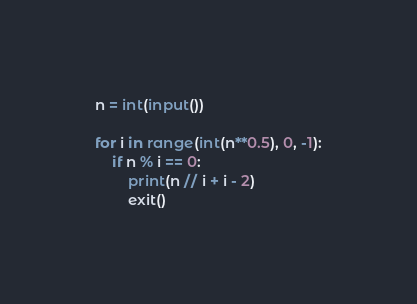<code> <loc_0><loc_0><loc_500><loc_500><_Python_>n = int(input())

for i in range(int(n**0.5), 0, -1):
    if n % i == 0:
        print(n // i + i - 2)
        exit()
</code> 